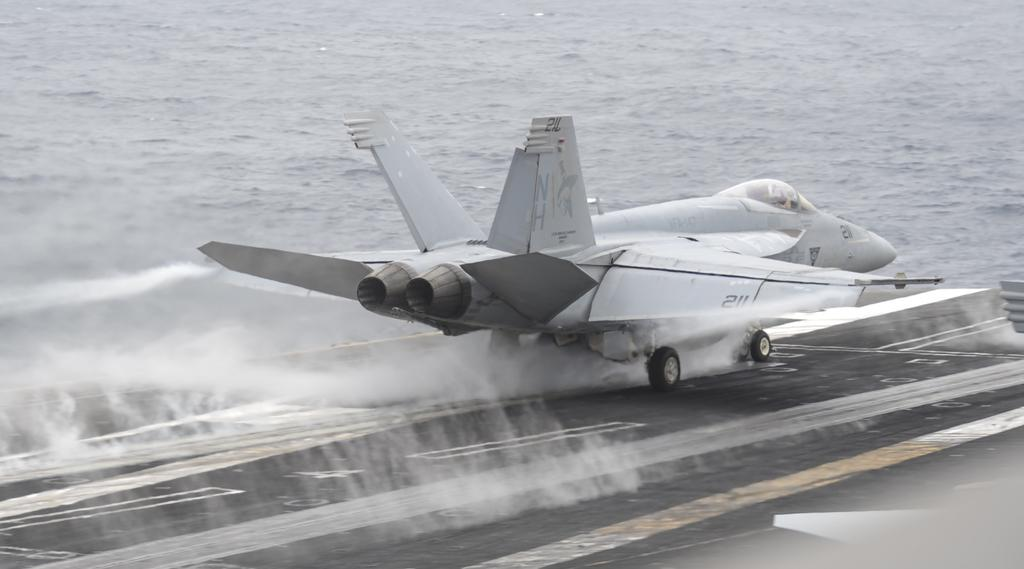What is the main subject of the picture? The main subject of the picture is an aircraft. What can be seen in the background of the picture? There is water visible in the picture. What type of man-made structure is present in the picture? There is a road in the picture. What type of cat can be seen wearing underwear in the image? There is no cat or underwear present in the image; it features an aircraft and water. What flavor of cake is being served on the road in the image? There is no cake present in the image; it features an aircraft, water, and a road. 